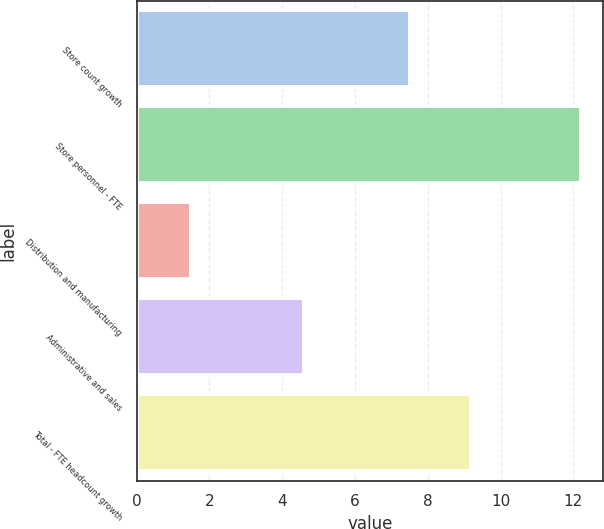Convert chart to OTSL. <chart><loc_0><loc_0><loc_500><loc_500><bar_chart><fcel>Store count growth<fcel>Store personnel - FTE<fcel>Distribution and manufacturing<fcel>Administrative and sales<fcel>Total - FTE headcount growth<nl><fcel>7.5<fcel>12.2<fcel>1.5<fcel>4.6<fcel>9.2<nl></chart> 